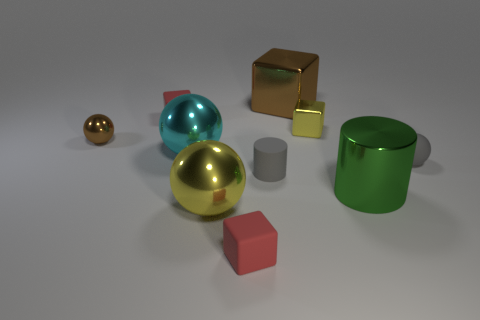Subtract all brown spheres. Subtract all green cylinders. How many spheres are left? 3 Subtract all cubes. How many objects are left? 6 Subtract all large cyan shiny objects. Subtract all brown blocks. How many objects are left? 8 Add 5 brown blocks. How many brown blocks are left? 6 Add 6 cyan shiny balls. How many cyan shiny balls exist? 7 Subtract 0 red spheres. How many objects are left? 10 